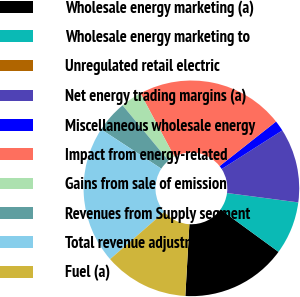Convert chart. <chart><loc_0><loc_0><loc_500><loc_500><pie_chart><fcel>Wholesale energy marketing (a)<fcel>Wholesale energy marketing to<fcel>Unregulated retail electric<fcel>Net energy trading margins (a)<fcel>Miscellaneous wholesale energy<fcel>Impact from energy-related<fcel>Gains from sale of emission<fcel>Revenues from Supply segment<fcel>Total revenue adjustments<fcel>Fuel (a)<nl><fcel>15.87%<fcel>7.94%<fcel>0.01%<fcel>11.11%<fcel>1.6%<fcel>22.21%<fcel>3.18%<fcel>4.77%<fcel>20.62%<fcel>12.7%<nl></chart> 